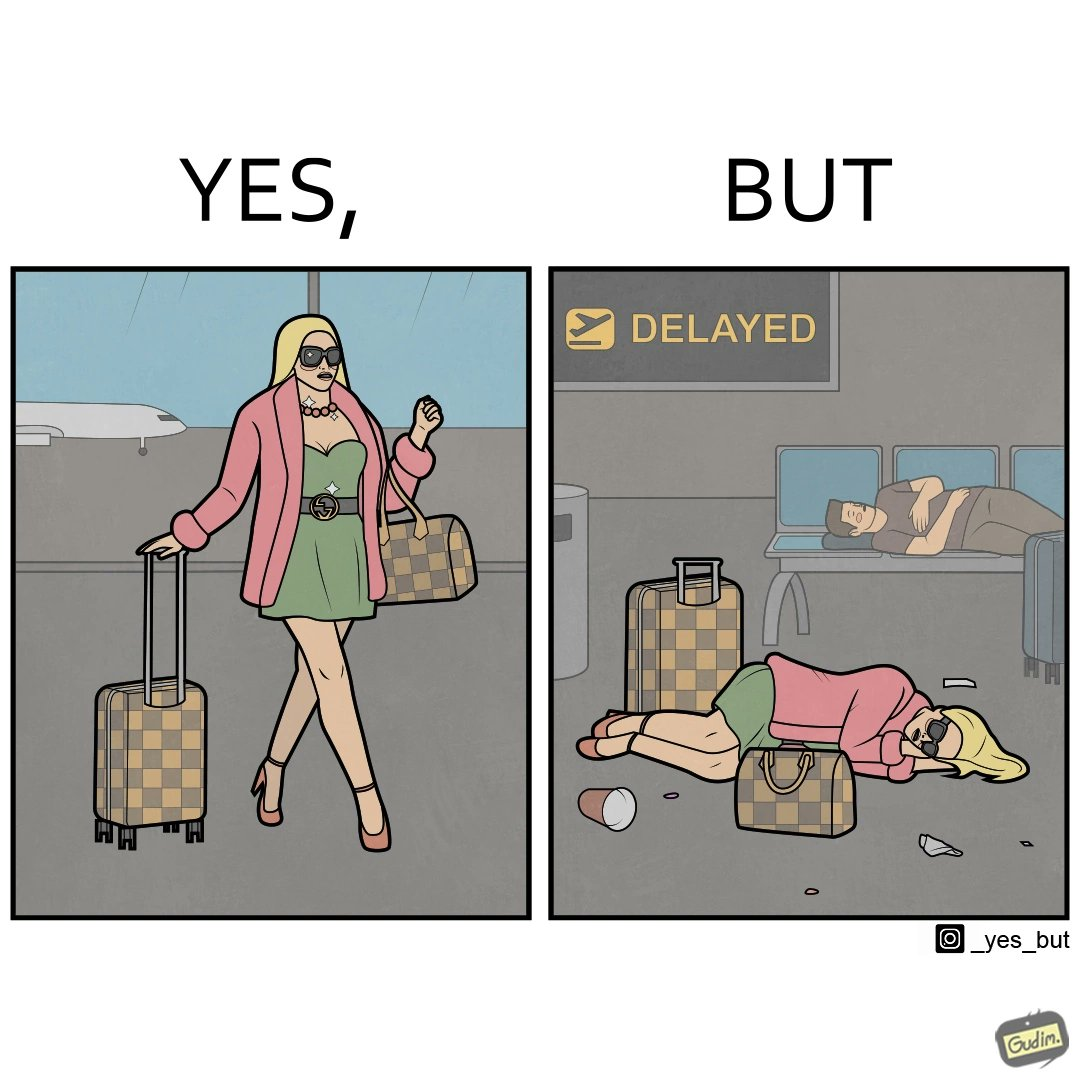Describe what you see in the left and right parts of this image. In the left part of the image: an apparently rich person walking inside the airport with luggage. In the right part of the image: a person sleeping on the floor of an airport with luggage due to a delayed flight and absence of vacant seats in the airport. 